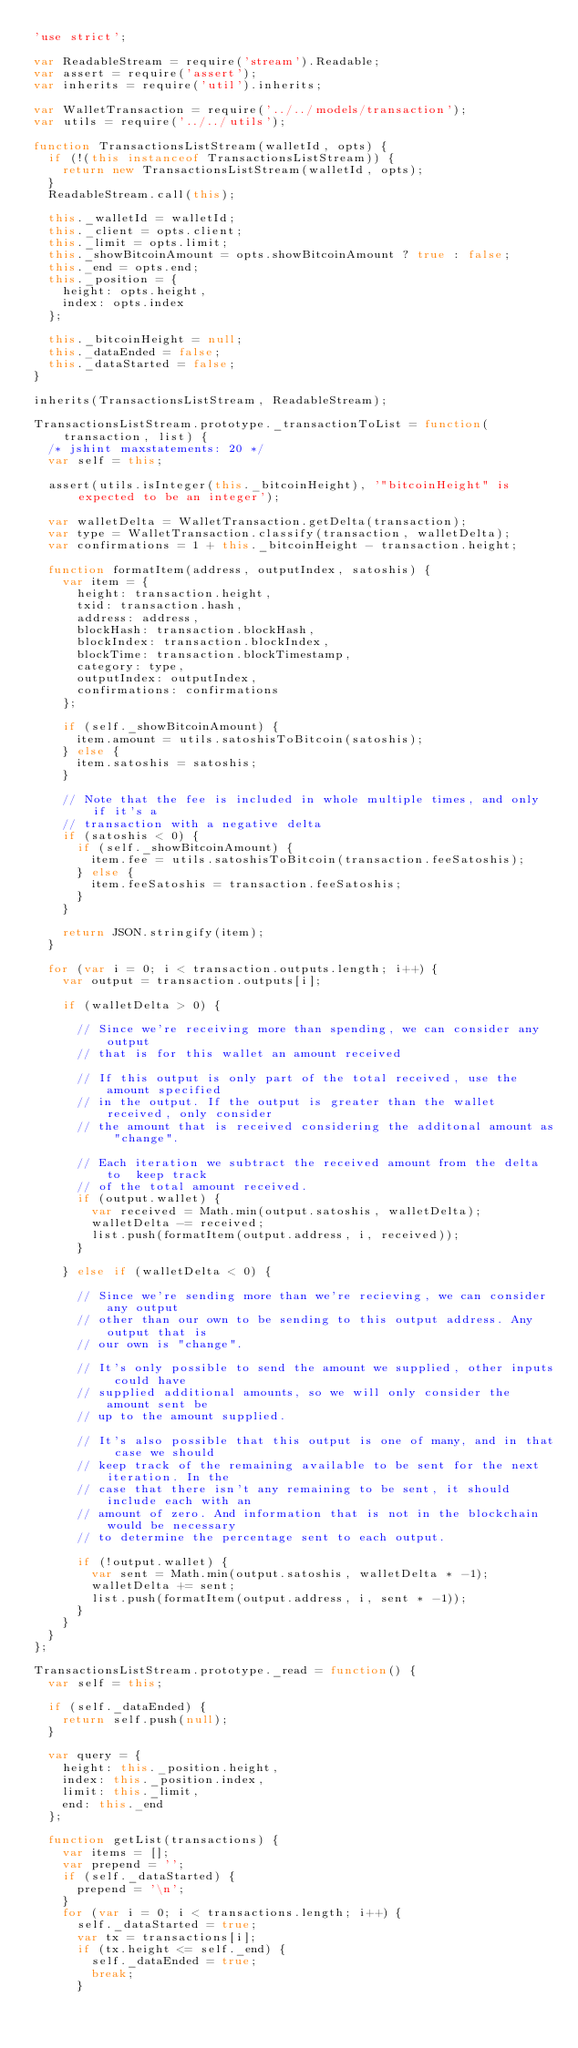<code> <loc_0><loc_0><loc_500><loc_500><_JavaScript_>'use strict';

var ReadableStream = require('stream').Readable;
var assert = require('assert');
var inherits = require('util').inherits;

var WalletTransaction = require('../../models/transaction');
var utils = require('../../utils');

function TransactionsListStream(walletId, opts) {
  if (!(this instanceof TransactionsListStream)) {
    return new TransactionsListStream(walletId, opts);
  }
  ReadableStream.call(this);

  this._walletId = walletId;
  this._client = opts.client;
  this._limit = opts.limit;
  this._showBitcoinAmount = opts.showBitcoinAmount ? true : false;
  this._end = opts.end;
  this._position = {
    height: opts.height,
    index: opts.index
  };

  this._bitcoinHeight = null;
  this._dataEnded = false;
  this._dataStarted = false;
}

inherits(TransactionsListStream, ReadableStream);

TransactionsListStream.prototype._transactionToList = function(transaction, list) {
  /* jshint maxstatements: 20 */
  var self = this;

  assert(utils.isInteger(this._bitcoinHeight), '"bitcoinHeight" is expected to be an integer');

  var walletDelta = WalletTransaction.getDelta(transaction);
  var type = WalletTransaction.classify(transaction, walletDelta);
  var confirmations = 1 + this._bitcoinHeight - transaction.height;

  function formatItem(address, outputIndex, satoshis) {
    var item = {
      height: transaction.height,
      txid: transaction.hash,
      address: address,
      blockHash: transaction.blockHash,
      blockIndex: transaction.blockIndex,
      blockTime: transaction.blockTimestamp,
      category: type,
      outputIndex: outputIndex,
      confirmations: confirmations
    };

    if (self._showBitcoinAmount) {
      item.amount = utils.satoshisToBitcoin(satoshis);
    } else {
      item.satoshis = satoshis;
    }

    // Note that the fee is included in whole multiple times, and only if it's a
    // transaction with a negative delta
    if (satoshis < 0) {
      if (self._showBitcoinAmount) {
        item.fee = utils.satoshisToBitcoin(transaction.feeSatoshis);
      } else {
        item.feeSatoshis = transaction.feeSatoshis;
      }
    }

    return JSON.stringify(item);
  }

  for (var i = 0; i < transaction.outputs.length; i++) {
    var output = transaction.outputs[i];

    if (walletDelta > 0) {

      // Since we're receiving more than spending, we can consider any output
      // that is for this wallet an amount received

      // If this output is only part of the total received, use the amount specified
      // in the output. If the output is greater than the wallet received, only consider
      // the amount that is received considering the additonal amount as "change".

      // Each iteration we subtract the received amount from the delta to  keep track
      // of the total amount received.
      if (output.wallet) {
        var received = Math.min(output.satoshis, walletDelta);
        walletDelta -= received;
        list.push(formatItem(output.address, i, received));
      }

    } else if (walletDelta < 0) {

      // Since we're sending more than we're recieving, we can consider any output
      // other than our own to be sending to this output address. Any output that is
      // our own is "change".

      // It's only possible to send the amount we supplied, other inputs could have
      // supplied additional amounts, so we will only consider the amount sent be
      // up to the amount supplied.

      // It's also possible that this output is one of many, and in that case we should
      // keep track of the remaining available to be sent for the next iteration. In the
      // case that there isn't any remaining to be sent, it should include each with an
      // amount of zero. And information that is not in the blockchain would be necessary
      // to determine the percentage sent to each output.

      if (!output.wallet) {
        var sent = Math.min(output.satoshis, walletDelta * -1);
        walletDelta += sent;
        list.push(formatItem(output.address, i, sent * -1));
      }
    }
  }
};

TransactionsListStream.prototype._read = function() {
  var self = this;

  if (self._dataEnded) {
    return self.push(null);
  }

  var query = {
    height: this._position.height,
    index: this._position.index,
    limit: this._limit,
    end: this._end
  };

  function getList(transactions) {
    var items = [];
    var prepend = '';
    if (self._dataStarted) {
      prepend = '\n';
    }
    for (var i = 0; i < transactions.length; i++) {
      self._dataStarted = true;
      var tx = transactions[i];
      if (tx.height <= self._end) {
        self._dataEnded = true;
        break;
      }</code> 